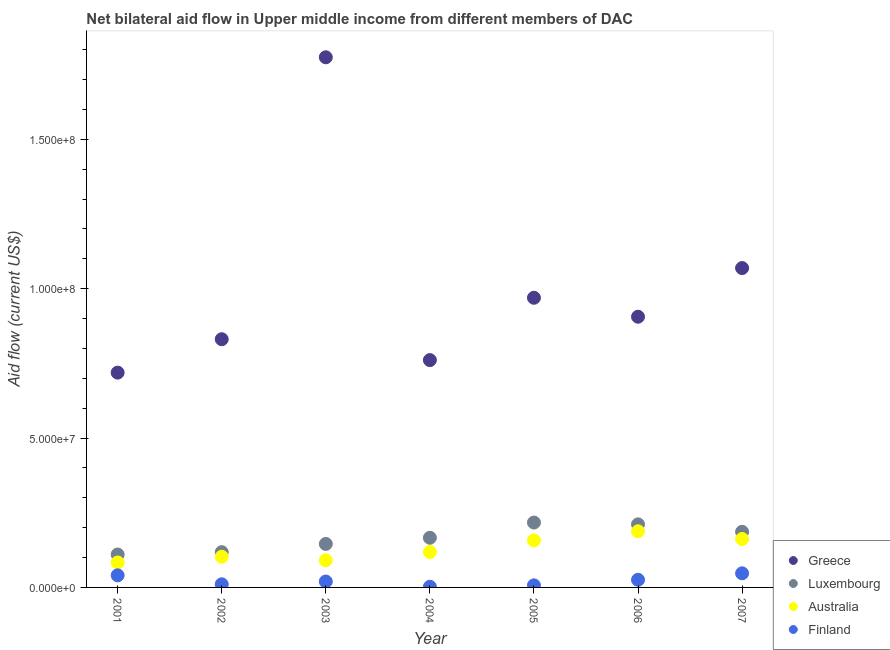How many different coloured dotlines are there?
Provide a short and direct response. 4. Is the number of dotlines equal to the number of legend labels?
Offer a terse response. Yes. What is the amount of aid given by australia in 2006?
Your response must be concise. 1.88e+07. Across all years, what is the maximum amount of aid given by finland?
Your answer should be very brief. 4.72e+06. Across all years, what is the minimum amount of aid given by greece?
Offer a terse response. 7.19e+07. In which year was the amount of aid given by finland maximum?
Provide a succinct answer. 2007. What is the total amount of aid given by greece in the graph?
Offer a very short reply. 7.03e+08. What is the difference between the amount of aid given by finland in 2001 and that in 2007?
Provide a short and direct response. -6.70e+05. What is the difference between the amount of aid given by greece in 2007 and the amount of aid given by finland in 2004?
Ensure brevity in your answer.  1.07e+08. What is the average amount of aid given by luxembourg per year?
Your answer should be compact. 1.65e+07. In the year 2007, what is the difference between the amount of aid given by finland and amount of aid given by greece?
Provide a succinct answer. -1.02e+08. In how many years, is the amount of aid given by finland greater than 120000000 US$?
Give a very brief answer. 0. What is the ratio of the amount of aid given by finland in 2004 to that in 2007?
Provide a succinct answer. 0.05. Is the amount of aid given by luxembourg in 2004 less than that in 2005?
Your response must be concise. Yes. What is the difference between the highest and the second highest amount of aid given by greece?
Your answer should be very brief. 7.06e+07. What is the difference between the highest and the lowest amount of aid given by australia?
Your answer should be compact. 1.04e+07. In how many years, is the amount of aid given by luxembourg greater than the average amount of aid given by luxembourg taken over all years?
Your answer should be very brief. 4. Is it the case that in every year, the sum of the amount of aid given by finland and amount of aid given by australia is greater than the sum of amount of aid given by luxembourg and amount of aid given by greece?
Ensure brevity in your answer.  No. Is the amount of aid given by finland strictly less than the amount of aid given by australia over the years?
Provide a short and direct response. Yes. How many dotlines are there?
Keep it short and to the point. 4. Are the values on the major ticks of Y-axis written in scientific E-notation?
Give a very brief answer. Yes. Does the graph contain grids?
Your answer should be very brief. No. Where does the legend appear in the graph?
Offer a very short reply. Bottom right. How many legend labels are there?
Your answer should be very brief. 4. What is the title of the graph?
Provide a succinct answer. Net bilateral aid flow in Upper middle income from different members of DAC. What is the label or title of the X-axis?
Your response must be concise. Year. What is the Aid flow (current US$) in Greece in 2001?
Your answer should be compact. 7.19e+07. What is the Aid flow (current US$) in Luxembourg in 2001?
Give a very brief answer. 1.10e+07. What is the Aid flow (current US$) in Australia in 2001?
Ensure brevity in your answer.  8.35e+06. What is the Aid flow (current US$) of Finland in 2001?
Your answer should be very brief. 4.05e+06. What is the Aid flow (current US$) of Greece in 2002?
Your answer should be compact. 8.31e+07. What is the Aid flow (current US$) of Luxembourg in 2002?
Your answer should be compact. 1.18e+07. What is the Aid flow (current US$) of Australia in 2002?
Provide a succinct answer. 1.03e+07. What is the Aid flow (current US$) in Finland in 2002?
Your answer should be compact. 1.05e+06. What is the Aid flow (current US$) of Greece in 2003?
Keep it short and to the point. 1.77e+08. What is the Aid flow (current US$) of Luxembourg in 2003?
Your answer should be very brief. 1.46e+07. What is the Aid flow (current US$) of Australia in 2003?
Keep it short and to the point. 9.08e+06. What is the Aid flow (current US$) of Finland in 2003?
Your answer should be very brief. 1.98e+06. What is the Aid flow (current US$) in Greece in 2004?
Keep it short and to the point. 7.61e+07. What is the Aid flow (current US$) of Luxembourg in 2004?
Your answer should be compact. 1.66e+07. What is the Aid flow (current US$) in Australia in 2004?
Give a very brief answer. 1.18e+07. What is the Aid flow (current US$) of Finland in 2004?
Offer a terse response. 2.20e+05. What is the Aid flow (current US$) of Greece in 2005?
Make the answer very short. 9.70e+07. What is the Aid flow (current US$) of Luxembourg in 2005?
Offer a very short reply. 2.17e+07. What is the Aid flow (current US$) in Australia in 2005?
Make the answer very short. 1.58e+07. What is the Aid flow (current US$) of Finland in 2005?
Make the answer very short. 6.90e+05. What is the Aid flow (current US$) of Greece in 2006?
Your answer should be compact. 9.06e+07. What is the Aid flow (current US$) of Luxembourg in 2006?
Keep it short and to the point. 2.11e+07. What is the Aid flow (current US$) in Australia in 2006?
Your answer should be compact. 1.88e+07. What is the Aid flow (current US$) of Finland in 2006?
Offer a very short reply. 2.56e+06. What is the Aid flow (current US$) in Greece in 2007?
Offer a terse response. 1.07e+08. What is the Aid flow (current US$) in Luxembourg in 2007?
Your answer should be compact. 1.86e+07. What is the Aid flow (current US$) in Australia in 2007?
Your answer should be compact. 1.62e+07. What is the Aid flow (current US$) in Finland in 2007?
Your answer should be very brief. 4.72e+06. Across all years, what is the maximum Aid flow (current US$) in Greece?
Your response must be concise. 1.77e+08. Across all years, what is the maximum Aid flow (current US$) in Luxembourg?
Your answer should be compact. 2.17e+07. Across all years, what is the maximum Aid flow (current US$) in Australia?
Give a very brief answer. 1.88e+07. Across all years, what is the maximum Aid flow (current US$) in Finland?
Provide a short and direct response. 4.72e+06. Across all years, what is the minimum Aid flow (current US$) in Greece?
Give a very brief answer. 7.19e+07. Across all years, what is the minimum Aid flow (current US$) of Luxembourg?
Provide a succinct answer. 1.10e+07. Across all years, what is the minimum Aid flow (current US$) of Australia?
Give a very brief answer. 8.35e+06. Across all years, what is the minimum Aid flow (current US$) of Finland?
Ensure brevity in your answer.  2.20e+05. What is the total Aid flow (current US$) of Greece in the graph?
Keep it short and to the point. 7.03e+08. What is the total Aid flow (current US$) in Luxembourg in the graph?
Provide a short and direct response. 1.15e+08. What is the total Aid flow (current US$) of Australia in the graph?
Offer a very short reply. 9.03e+07. What is the total Aid flow (current US$) of Finland in the graph?
Provide a short and direct response. 1.53e+07. What is the difference between the Aid flow (current US$) in Greece in 2001 and that in 2002?
Your answer should be very brief. -1.12e+07. What is the difference between the Aid flow (current US$) in Luxembourg in 2001 and that in 2002?
Provide a short and direct response. -7.80e+05. What is the difference between the Aid flow (current US$) of Australia in 2001 and that in 2002?
Provide a succinct answer. -1.92e+06. What is the difference between the Aid flow (current US$) of Greece in 2001 and that in 2003?
Provide a short and direct response. -1.06e+08. What is the difference between the Aid flow (current US$) in Luxembourg in 2001 and that in 2003?
Offer a very short reply. -3.54e+06. What is the difference between the Aid flow (current US$) of Australia in 2001 and that in 2003?
Give a very brief answer. -7.30e+05. What is the difference between the Aid flow (current US$) in Finland in 2001 and that in 2003?
Ensure brevity in your answer.  2.07e+06. What is the difference between the Aid flow (current US$) of Greece in 2001 and that in 2004?
Your answer should be very brief. -4.19e+06. What is the difference between the Aid flow (current US$) in Luxembourg in 2001 and that in 2004?
Your answer should be very brief. -5.61e+06. What is the difference between the Aid flow (current US$) of Australia in 2001 and that in 2004?
Provide a short and direct response. -3.50e+06. What is the difference between the Aid flow (current US$) of Finland in 2001 and that in 2004?
Provide a short and direct response. 3.83e+06. What is the difference between the Aid flow (current US$) in Greece in 2001 and that in 2005?
Provide a short and direct response. -2.51e+07. What is the difference between the Aid flow (current US$) of Luxembourg in 2001 and that in 2005?
Make the answer very short. -1.07e+07. What is the difference between the Aid flow (current US$) of Australia in 2001 and that in 2005?
Keep it short and to the point. -7.40e+06. What is the difference between the Aid flow (current US$) of Finland in 2001 and that in 2005?
Give a very brief answer. 3.36e+06. What is the difference between the Aid flow (current US$) of Greece in 2001 and that in 2006?
Offer a very short reply. -1.87e+07. What is the difference between the Aid flow (current US$) of Luxembourg in 2001 and that in 2006?
Provide a short and direct response. -1.01e+07. What is the difference between the Aid flow (current US$) of Australia in 2001 and that in 2006?
Offer a terse response. -1.04e+07. What is the difference between the Aid flow (current US$) in Finland in 2001 and that in 2006?
Give a very brief answer. 1.49e+06. What is the difference between the Aid flow (current US$) of Greece in 2001 and that in 2007?
Ensure brevity in your answer.  -3.50e+07. What is the difference between the Aid flow (current US$) of Luxembourg in 2001 and that in 2007?
Offer a terse response. -7.61e+06. What is the difference between the Aid flow (current US$) in Australia in 2001 and that in 2007?
Your response must be concise. -7.87e+06. What is the difference between the Aid flow (current US$) in Finland in 2001 and that in 2007?
Ensure brevity in your answer.  -6.70e+05. What is the difference between the Aid flow (current US$) of Greece in 2002 and that in 2003?
Give a very brief answer. -9.44e+07. What is the difference between the Aid flow (current US$) of Luxembourg in 2002 and that in 2003?
Your answer should be compact. -2.76e+06. What is the difference between the Aid flow (current US$) in Australia in 2002 and that in 2003?
Your answer should be very brief. 1.19e+06. What is the difference between the Aid flow (current US$) in Finland in 2002 and that in 2003?
Your answer should be compact. -9.30e+05. What is the difference between the Aid flow (current US$) of Greece in 2002 and that in 2004?
Ensure brevity in your answer.  6.99e+06. What is the difference between the Aid flow (current US$) of Luxembourg in 2002 and that in 2004?
Give a very brief answer. -4.83e+06. What is the difference between the Aid flow (current US$) in Australia in 2002 and that in 2004?
Ensure brevity in your answer.  -1.58e+06. What is the difference between the Aid flow (current US$) of Finland in 2002 and that in 2004?
Your response must be concise. 8.30e+05. What is the difference between the Aid flow (current US$) in Greece in 2002 and that in 2005?
Your response must be concise. -1.39e+07. What is the difference between the Aid flow (current US$) of Luxembourg in 2002 and that in 2005?
Provide a short and direct response. -9.92e+06. What is the difference between the Aid flow (current US$) in Australia in 2002 and that in 2005?
Make the answer very short. -5.48e+06. What is the difference between the Aid flow (current US$) in Finland in 2002 and that in 2005?
Provide a short and direct response. 3.60e+05. What is the difference between the Aid flow (current US$) of Greece in 2002 and that in 2006?
Provide a succinct answer. -7.53e+06. What is the difference between the Aid flow (current US$) in Luxembourg in 2002 and that in 2006?
Make the answer very short. -9.31e+06. What is the difference between the Aid flow (current US$) of Australia in 2002 and that in 2006?
Offer a very short reply. -8.53e+06. What is the difference between the Aid flow (current US$) in Finland in 2002 and that in 2006?
Offer a terse response. -1.51e+06. What is the difference between the Aid flow (current US$) in Greece in 2002 and that in 2007?
Ensure brevity in your answer.  -2.38e+07. What is the difference between the Aid flow (current US$) of Luxembourg in 2002 and that in 2007?
Offer a very short reply. -6.83e+06. What is the difference between the Aid flow (current US$) of Australia in 2002 and that in 2007?
Provide a short and direct response. -5.95e+06. What is the difference between the Aid flow (current US$) of Finland in 2002 and that in 2007?
Give a very brief answer. -3.67e+06. What is the difference between the Aid flow (current US$) in Greece in 2003 and that in 2004?
Offer a very short reply. 1.01e+08. What is the difference between the Aid flow (current US$) in Luxembourg in 2003 and that in 2004?
Your answer should be very brief. -2.07e+06. What is the difference between the Aid flow (current US$) of Australia in 2003 and that in 2004?
Offer a very short reply. -2.77e+06. What is the difference between the Aid flow (current US$) in Finland in 2003 and that in 2004?
Your response must be concise. 1.76e+06. What is the difference between the Aid flow (current US$) in Greece in 2003 and that in 2005?
Your response must be concise. 8.05e+07. What is the difference between the Aid flow (current US$) in Luxembourg in 2003 and that in 2005?
Offer a terse response. -7.16e+06. What is the difference between the Aid flow (current US$) in Australia in 2003 and that in 2005?
Your answer should be compact. -6.67e+06. What is the difference between the Aid flow (current US$) of Finland in 2003 and that in 2005?
Offer a very short reply. 1.29e+06. What is the difference between the Aid flow (current US$) of Greece in 2003 and that in 2006?
Your answer should be compact. 8.68e+07. What is the difference between the Aid flow (current US$) of Luxembourg in 2003 and that in 2006?
Offer a very short reply. -6.55e+06. What is the difference between the Aid flow (current US$) of Australia in 2003 and that in 2006?
Offer a very short reply. -9.72e+06. What is the difference between the Aid flow (current US$) of Finland in 2003 and that in 2006?
Ensure brevity in your answer.  -5.80e+05. What is the difference between the Aid flow (current US$) in Greece in 2003 and that in 2007?
Offer a very short reply. 7.06e+07. What is the difference between the Aid flow (current US$) of Luxembourg in 2003 and that in 2007?
Your answer should be very brief. -4.07e+06. What is the difference between the Aid flow (current US$) in Australia in 2003 and that in 2007?
Make the answer very short. -7.14e+06. What is the difference between the Aid flow (current US$) in Finland in 2003 and that in 2007?
Make the answer very short. -2.74e+06. What is the difference between the Aid flow (current US$) in Greece in 2004 and that in 2005?
Provide a succinct answer. -2.09e+07. What is the difference between the Aid flow (current US$) of Luxembourg in 2004 and that in 2005?
Ensure brevity in your answer.  -5.09e+06. What is the difference between the Aid flow (current US$) in Australia in 2004 and that in 2005?
Provide a succinct answer. -3.90e+06. What is the difference between the Aid flow (current US$) in Finland in 2004 and that in 2005?
Give a very brief answer. -4.70e+05. What is the difference between the Aid flow (current US$) of Greece in 2004 and that in 2006?
Keep it short and to the point. -1.45e+07. What is the difference between the Aid flow (current US$) in Luxembourg in 2004 and that in 2006?
Offer a very short reply. -4.48e+06. What is the difference between the Aid flow (current US$) in Australia in 2004 and that in 2006?
Provide a succinct answer. -6.95e+06. What is the difference between the Aid flow (current US$) in Finland in 2004 and that in 2006?
Your answer should be very brief. -2.34e+06. What is the difference between the Aid flow (current US$) of Greece in 2004 and that in 2007?
Keep it short and to the point. -3.08e+07. What is the difference between the Aid flow (current US$) in Luxembourg in 2004 and that in 2007?
Give a very brief answer. -2.00e+06. What is the difference between the Aid flow (current US$) of Australia in 2004 and that in 2007?
Make the answer very short. -4.37e+06. What is the difference between the Aid flow (current US$) of Finland in 2004 and that in 2007?
Your answer should be compact. -4.50e+06. What is the difference between the Aid flow (current US$) of Greece in 2005 and that in 2006?
Ensure brevity in your answer.  6.35e+06. What is the difference between the Aid flow (current US$) of Luxembourg in 2005 and that in 2006?
Give a very brief answer. 6.10e+05. What is the difference between the Aid flow (current US$) in Australia in 2005 and that in 2006?
Offer a very short reply. -3.05e+06. What is the difference between the Aid flow (current US$) of Finland in 2005 and that in 2006?
Your response must be concise. -1.87e+06. What is the difference between the Aid flow (current US$) in Greece in 2005 and that in 2007?
Your answer should be very brief. -9.94e+06. What is the difference between the Aid flow (current US$) of Luxembourg in 2005 and that in 2007?
Provide a succinct answer. 3.09e+06. What is the difference between the Aid flow (current US$) in Australia in 2005 and that in 2007?
Provide a succinct answer. -4.70e+05. What is the difference between the Aid flow (current US$) of Finland in 2005 and that in 2007?
Offer a very short reply. -4.03e+06. What is the difference between the Aid flow (current US$) of Greece in 2006 and that in 2007?
Make the answer very short. -1.63e+07. What is the difference between the Aid flow (current US$) of Luxembourg in 2006 and that in 2007?
Make the answer very short. 2.48e+06. What is the difference between the Aid flow (current US$) of Australia in 2006 and that in 2007?
Keep it short and to the point. 2.58e+06. What is the difference between the Aid flow (current US$) in Finland in 2006 and that in 2007?
Keep it short and to the point. -2.16e+06. What is the difference between the Aid flow (current US$) in Greece in 2001 and the Aid flow (current US$) in Luxembourg in 2002?
Offer a terse response. 6.01e+07. What is the difference between the Aid flow (current US$) of Greece in 2001 and the Aid flow (current US$) of Australia in 2002?
Give a very brief answer. 6.16e+07. What is the difference between the Aid flow (current US$) of Greece in 2001 and the Aid flow (current US$) of Finland in 2002?
Make the answer very short. 7.09e+07. What is the difference between the Aid flow (current US$) of Luxembourg in 2001 and the Aid flow (current US$) of Australia in 2002?
Keep it short and to the point. 7.50e+05. What is the difference between the Aid flow (current US$) in Luxembourg in 2001 and the Aid flow (current US$) in Finland in 2002?
Provide a succinct answer. 9.97e+06. What is the difference between the Aid flow (current US$) in Australia in 2001 and the Aid flow (current US$) in Finland in 2002?
Provide a short and direct response. 7.30e+06. What is the difference between the Aid flow (current US$) of Greece in 2001 and the Aid flow (current US$) of Luxembourg in 2003?
Offer a terse response. 5.74e+07. What is the difference between the Aid flow (current US$) in Greece in 2001 and the Aid flow (current US$) in Australia in 2003?
Make the answer very short. 6.28e+07. What is the difference between the Aid flow (current US$) of Greece in 2001 and the Aid flow (current US$) of Finland in 2003?
Make the answer very short. 6.99e+07. What is the difference between the Aid flow (current US$) in Luxembourg in 2001 and the Aid flow (current US$) in Australia in 2003?
Provide a short and direct response. 1.94e+06. What is the difference between the Aid flow (current US$) in Luxembourg in 2001 and the Aid flow (current US$) in Finland in 2003?
Ensure brevity in your answer.  9.04e+06. What is the difference between the Aid flow (current US$) of Australia in 2001 and the Aid flow (current US$) of Finland in 2003?
Your answer should be very brief. 6.37e+06. What is the difference between the Aid flow (current US$) of Greece in 2001 and the Aid flow (current US$) of Luxembourg in 2004?
Keep it short and to the point. 5.53e+07. What is the difference between the Aid flow (current US$) in Greece in 2001 and the Aid flow (current US$) in Australia in 2004?
Your response must be concise. 6.01e+07. What is the difference between the Aid flow (current US$) of Greece in 2001 and the Aid flow (current US$) of Finland in 2004?
Offer a very short reply. 7.17e+07. What is the difference between the Aid flow (current US$) of Luxembourg in 2001 and the Aid flow (current US$) of Australia in 2004?
Offer a terse response. -8.30e+05. What is the difference between the Aid flow (current US$) in Luxembourg in 2001 and the Aid flow (current US$) in Finland in 2004?
Give a very brief answer. 1.08e+07. What is the difference between the Aid flow (current US$) of Australia in 2001 and the Aid flow (current US$) of Finland in 2004?
Offer a terse response. 8.13e+06. What is the difference between the Aid flow (current US$) in Greece in 2001 and the Aid flow (current US$) in Luxembourg in 2005?
Your answer should be very brief. 5.02e+07. What is the difference between the Aid flow (current US$) of Greece in 2001 and the Aid flow (current US$) of Australia in 2005?
Give a very brief answer. 5.62e+07. What is the difference between the Aid flow (current US$) of Greece in 2001 and the Aid flow (current US$) of Finland in 2005?
Offer a very short reply. 7.12e+07. What is the difference between the Aid flow (current US$) in Luxembourg in 2001 and the Aid flow (current US$) in Australia in 2005?
Provide a short and direct response. -4.73e+06. What is the difference between the Aid flow (current US$) in Luxembourg in 2001 and the Aid flow (current US$) in Finland in 2005?
Your response must be concise. 1.03e+07. What is the difference between the Aid flow (current US$) of Australia in 2001 and the Aid flow (current US$) of Finland in 2005?
Ensure brevity in your answer.  7.66e+06. What is the difference between the Aid flow (current US$) of Greece in 2001 and the Aid flow (current US$) of Luxembourg in 2006?
Provide a succinct answer. 5.08e+07. What is the difference between the Aid flow (current US$) of Greece in 2001 and the Aid flow (current US$) of Australia in 2006?
Your response must be concise. 5.31e+07. What is the difference between the Aid flow (current US$) of Greece in 2001 and the Aid flow (current US$) of Finland in 2006?
Offer a terse response. 6.94e+07. What is the difference between the Aid flow (current US$) of Luxembourg in 2001 and the Aid flow (current US$) of Australia in 2006?
Ensure brevity in your answer.  -7.78e+06. What is the difference between the Aid flow (current US$) of Luxembourg in 2001 and the Aid flow (current US$) of Finland in 2006?
Offer a terse response. 8.46e+06. What is the difference between the Aid flow (current US$) in Australia in 2001 and the Aid flow (current US$) in Finland in 2006?
Offer a very short reply. 5.79e+06. What is the difference between the Aid flow (current US$) in Greece in 2001 and the Aid flow (current US$) in Luxembourg in 2007?
Your answer should be very brief. 5.33e+07. What is the difference between the Aid flow (current US$) of Greece in 2001 and the Aid flow (current US$) of Australia in 2007?
Offer a terse response. 5.57e+07. What is the difference between the Aid flow (current US$) in Greece in 2001 and the Aid flow (current US$) in Finland in 2007?
Your answer should be compact. 6.72e+07. What is the difference between the Aid flow (current US$) of Luxembourg in 2001 and the Aid flow (current US$) of Australia in 2007?
Offer a very short reply. -5.20e+06. What is the difference between the Aid flow (current US$) in Luxembourg in 2001 and the Aid flow (current US$) in Finland in 2007?
Provide a short and direct response. 6.30e+06. What is the difference between the Aid flow (current US$) in Australia in 2001 and the Aid flow (current US$) in Finland in 2007?
Keep it short and to the point. 3.63e+06. What is the difference between the Aid flow (current US$) in Greece in 2002 and the Aid flow (current US$) in Luxembourg in 2003?
Provide a short and direct response. 6.85e+07. What is the difference between the Aid flow (current US$) in Greece in 2002 and the Aid flow (current US$) in Australia in 2003?
Give a very brief answer. 7.40e+07. What is the difference between the Aid flow (current US$) of Greece in 2002 and the Aid flow (current US$) of Finland in 2003?
Offer a very short reply. 8.11e+07. What is the difference between the Aid flow (current US$) in Luxembourg in 2002 and the Aid flow (current US$) in Australia in 2003?
Your answer should be compact. 2.72e+06. What is the difference between the Aid flow (current US$) in Luxembourg in 2002 and the Aid flow (current US$) in Finland in 2003?
Keep it short and to the point. 9.82e+06. What is the difference between the Aid flow (current US$) in Australia in 2002 and the Aid flow (current US$) in Finland in 2003?
Provide a succinct answer. 8.29e+06. What is the difference between the Aid flow (current US$) in Greece in 2002 and the Aid flow (current US$) in Luxembourg in 2004?
Your answer should be compact. 6.65e+07. What is the difference between the Aid flow (current US$) of Greece in 2002 and the Aid flow (current US$) of Australia in 2004?
Ensure brevity in your answer.  7.12e+07. What is the difference between the Aid flow (current US$) of Greece in 2002 and the Aid flow (current US$) of Finland in 2004?
Your answer should be compact. 8.29e+07. What is the difference between the Aid flow (current US$) in Luxembourg in 2002 and the Aid flow (current US$) in Finland in 2004?
Your response must be concise. 1.16e+07. What is the difference between the Aid flow (current US$) in Australia in 2002 and the Aid flow (current US$) in Finland in 2004?
Your answer should be compact. 1.00e+07. What is the difference between the Aid flow (current US$) of Greece in 2002 and the Aid flow (current US$) of Luxembourg in 2005?
Provide a short and direct response. 6.14e+07. What is the difference between the Aid flow (current US$) of Greece in 2002 and the Aid flow (current US$) of Australia in 2005?
Make the answer very short. 6.73e+07. What is the difference between the Aid flow (current US$) in Greece in 2002 and the Aid flow (current US$) in Finland in 2005?
Your answer should be very brief. 8.24e+07. What is the difference between the Aid flow (current US$) of Luxembourg in 2002 and the Aid flow (current US$) of Australia in 2005?
Make the answer very short. -3.95e+06. What is the difference between the Aid flow (current US$) in Luxembourg in 2002 and the Aid flow (current US$) in Finland in 2005?
Give a very brief answer. 1.11e+07. What is the difference between the Aid flow (current US$) in Australia in 2002 and the Aid flow (current US$) in Finland in 2005?
Provide a short and direct response. 9.58e+06. What is the difference between the Aid flow (current US$) of Greece in 2002 and the Aid flow (current US$) of Luxembourg in 2006?
Offer a very short reply. 6.20e+07. What is the difference between the Aid flow (current US$) in Greece in 2002 and the Aid flow (current US$) in Australia in 2006?
Offer a terse response. 6.43e+07. What is the difference between the Aid flow (current US$) in Greece in 2002 and the Aid flow (current US$) in Finland in 2006?
Offer a terse response. 8.05e+07. What is the difference between the Aid flow (current US$) of Luxembourg in 2002 and the Aid flow (current US$) of Australia in 2006?
Give a very brief answer. -7.00e+06. What is the difference between the Aid flow (current US$) of Luxembourg in 2002 and the Aid flow (current US$) of Finland in 2006?
Make the answer very short. 9.24e+06. What is the difference between the Aid flow (current US$) in Australia in 2002 and the Aid flow (current US$) in Finland in 2006?
Offer a very short reply. 7.71e+06. What is the difference between the Aid flow (current US$) of Greece in 2002 and the Aid flow (current US$) of Luxembourg in 2007?
Your answer should be compact. 6.45e+07. What is the difference between the Aid flow (current US$) of Greece in 2002 and the Aid flow (current US$) of Australia in 2007?
Ensure brevity in your answer.  6.69e+07. What is the difference between the Aid flow (current US$) of Greece in 2002 and the Aid flow (current US$) of Finland in 2007?
Your answer should be very brief. 7.84e+07. What is the difference between the Aid flow (current US$) in Luxembourg in 2002 and the Aid flow (current US$) in Australia in 2007?
Provide a succinct answer. -4.42e+06. What is the difference between the Aid flow (current US$) in Luxembourg in 2002 and the Aid flow (current US$) in Finland in 2007?
Offer a terse response. 7.08e+06. What is the difference between the Aid flow (current US$) of Australia in 2002 and the Aid flow (current US$) of Finland in 2007?
Provide a succinct answer. 5.55e+06. What is the difference between the Aid flow (current US$) of Greece in 2003 and the Aid flow (current US$) of Luxembourg in 2004?
Your answer should be very brief. 1.61e+08. What is the difference between the Aid flow (current US$) in Greece in 2003 and the Aid flow (current US$) in Australia in 2004?
Offer a very short reply. 1.66e+08. What is the difference between the Aid flow (current US$) of Greece in 2003 and the Aid flow (current US$) of Finland in 2004?
Provide a succinct answer. 1.77e+08. What is the difference between the Aid flow (current US$) of Luxembourg in 2003 and the Aid flow (current US$) of Australia in 2004?
Provide a succinct answer. 2.71e+06. What is the difference between the Aid flow (current US$) of Luxembourg in 2003 and the Aid flow (current US$) of Finland in 2004?
Provide a short and direct response. 1.43e+07. What is the difference between the Aid flow (current US$) of Australia in 2003 and the Aid flow (current US$) of Finland in 2004?
Offer a very short reply. 8.86e+06. What is the difference between the Aid flow (current US$) in Greece in 2003 and the Aid flow (current US$) in Luxembourg in 2005?
Offer a very short reply. 1.56e+08. What is the difference between the Aid flow (current US$) of Greece in 2003 and the Aid flow (current US$) of Australia in 2005?
Your answer should be compact. 1.62e+08. What is the difference between the Aid flow (current US$) in Greece in 2003 and the Aid flow (current US$) in Finland in 2005?
Give a very brief answer. 1.77e+08. What is the difference between the Aid flow (current US$) of Luxembourg in 2003 and the Aid flow (current US$) of Australia in 2005?
Give a very brief answer. -1.19e+06. What is the difference between the Aid flow (current US$) of Luxembourg in 2003 and the Aid flow (current US$) of Finland in 2005?
Provide a succinct answer. 1.39e+07. What is the difference between the Aid flow (current US$) of Australia in 2003 and the Aid flow (current US$) of Finland in 2005?
Ensure brevity in your answer.  8.39e+06. What is the difference between the Aid flow (current US$) of Greece in 2003 and the Aid flow (current US$) of Luxembourg in 2006?
Keep it short and to the point. 1.56e+08. What is the difference between the Aid flow (current US$) in Greece in 2003 and the Aid flow (current US$) in Australia in 2006?
Keep it short and to the point. 1.59e+08. What is the difference between the Aid flow (current US$) in Greece in 2003 and the Aid flow (current US$) in Finland in 2006?
Offer a very short reply. 1.75e+08. What is the difference between the Aid flow (current US$) in Luxembourg in 2003 and the Aid flow (current US$) in Australia in 2006?
Offer a very short reply. -4.24e+06. What is the difference between the Aid flow (current US$) of Luxembourg in 2003 and the Aid flow (current US$) of Finland in 2006?
Ensure brevity in your answer.  1.20e+07. What is the difference between the Aid flow (current US$) of Australia in 2003 and the Aid flow (current US$) of Finland in 2006?
Provide a succinct answer. 6.52e+06. What is the difference between the Aid flow (current US$) in Greece in 2003 and the Aid flow (current US$) in Luxembourg in 2007?
Offer a terse response. 1.59e+08. What is the difference between the Aid flow (current US$) in Greece in 2003 and the Aid flow (current US$) in Australia in 2007?
Offer a terse response. 1.61e+08. What is the difference between the Aid flow (current US$) in Greece in 2003 and the Aid flow (current US$) in Finland in 2007?
Offer a very short reply. 1.73e+08. What is the difference between the Aid flow (current US$) in Luxembourg in 2003 and the Aid flow (current US$) in Australia in 2007?
Ensure brevity in your answer.  -1.66e+06. What is the difference between the Aid flow (current US$) of Luxembourg in 2003 and the Aid flow (current US$) of Finland in 2007?
Give a very brief answer. 9.84e+06. What is the difference between the Aid flow (current US$) of Australia in 2003 and the Aid flow (current US$) of Finland in 2007?
Offer a very short reply. 4.36e+06. What is the difference between the Aid flow (current US$) of Greece in 2004 and the Aid flow (current US$) of Luxembourg in 2005?
Provide a succinct answer. 5.44e+07. What is the difference between the Aid flow (current US$) in Greece in 2004 and the Aid flow (current US$) in Australia in 2005?
Provide a short and direct response. 6.04e+07. What is the difference between the Aid flow (current US$) of Greece in 2004 and the Aid flow (current US$) of Finland in 2005?
Your answer should be very brief. 7.54e+07. What is the difference between the Aid flow (current US$) in Luxembourg in 2004 and the Aid flow (current US$) in Australia in 2005?
Make the answer very short. 8.80e+05. What is the difference between the Aid flow (current US$) of Luxembourg in 2004 and the Aid flow (current US$) of Finland in 2005?
Provide a succinct answer. 1.59e+07. What is the difference between the Aid flow (current US$) of Australia in 2004 and the Aid flow (current US$) of Finland in 2005?
Offer a very short reply. 1.12e+07. What is the difference between the Aid flow (current US$) of Greece in 2004 and the Aid flow (current US$) of Luxembourg in 2006?
Your answer should be very brief. 5.50e+07. What is the difference between the Aid flow (current US$) of Greece in 2004 and the Aid flow (current US$) of Australia in 2006?
Your response must be concise. 5.73e+07. What is the difference between the Aid flow (current US$) in Greece in 2004 and the Aid flow (current US$) in Finland in 2006?
Keep it short and to the point. 7.35e+07. What is the difference between the Aid flow (current US$) of Luxembourg in 2004 and the Aid flow (current US$) of Australia in 2006?
Offer a terse response. -2.17e+06. What is the difference between the Aid flow (current US$) of Luxembourg in 2004 and the Aid flow (current US$) of Finland in 2006?
Provide a short and direct response. 1.41e+07. What is the difference between the Aid flow (current US$) of Australia in 2004 and the Aid flow (current US$) of Finland in 2006?
Provide a short and direct response. 9.29e+06. What is the difference between the Aid flow (current US$) of Greece in 2004 and the Aid flow (current US$) of Luxembourg in 2007?
Keep it short and to the point. 5.75e+07. What is the difference between the Aid flow (current US$) in Greece in 2004 and the Aid flow (current US$) in Australia in 2007?
Your answer should be very brief. 5.99e+07. What is the difference between the Aid flow (current US$) of Greece in 2004 and the Aid flow (current US$) of Finland in 2007?
Keep it short and to the point. 7.14e+07. What is the difference between the Aid flow (current US$) of Luxembourg in 2004 and the Aid flow (current US$) of Australia in 2007?
Your response must be concise. 4.10e+05. What is the difference between the Aid flow (current US$) of Luxembourg in 2004 and the Aid flow (current US$) of Finland in 2007?
Provide a short and direct response. 1.19e+07. What is the difference between the Aid flow (current US$) in Australia in 2004 and the Aid flow (current US$) in Finland in 2007?
Ensure brevity in your answer.  7.13e+06. What is the difference between the Aid flow (current US$) in Greece in 2005 and the Aid flow (current US$) in Luxembourg in 2006?
Give a very brief answer. 7.59e+07. What is the difference between the Aid flow (current US$) in Greece in 2005 and the Aid flow (current US$) in Australia in 2006?
Keep it short and to the point. 7.82e+07. What is the difference between the Aid flow (current US$) in Greece in 2005 and the Aid flow (current US$) in Finland in 2006?
Ensure brevity in your answer.  9.44e+07. What is the difference between the Aid flow (current US$) of Luxembourg in 2005 and the Aid flow (current US$) of Australia in 2006?
Make the answer very short. 2.92e+06. What is the difference between the Aid flow (current US$) of Luxembourg in 2005 and the Aid flow (current US$) of Finland in 2006?
Keep it short and to the point. 1.92e+07. What is the difference between the Aid flow (current US$) of Australia in 2005 and the Aid flow (current US$) of Finland in 2006?
Offer a very short reply. 1.32e+07. What is the difference between the Aid flow (current US$) of Greece in 2005 and the Aid flow (current US$) of Luxembourg in 2007?
Give a very brief answer. 7.83e+07. What is the difference between the Aid flow (current US$) in Greece in 2005 and the Aid flow (current US$) in Australia in 2007?
Provide a short and direct response. 8.08e+07. What is the difference between the Aid flow (current US$) in Greece in 2005 and the Aid flow (current US$) in Finland in 2007?
Provide a short and direct response. 9.22e+07. What is the difference between the Aid flow (current US$) in Luxembourg in 2005 and the Aid flow (current US$) in Australia in 2007?
Your response must be concise. 5.50e+06. What is the difference between the Aid flow (current US$) in Luxembourg in 2005 and the Aid flow (current US$) in Finland in 2007?
Make the answer very short. 1.70e+07. What is the difference between the Aid flow (current US$) in Australia in 2005 and the Aid flow (current US$) in Finland in 2007?
Ensure brevity in your answer.  1.10e+07. What is the difference between the Aid flow (current US$) of Greece in 2006 and the Aid flow (current US$) of Luxembourg in 2007?
Offer a very short reply. 7.20e+07. What is the difference between the Aid flow (current US$) in Greece in 2006 and the Aid flow (current US$) in Australia in 2007?
Provide a short and direct response. 7.44e+07. What is the difference between the Aid flow (current US$) of Greece in 2006 and the Aid flow (current US$) of Finland in 2007?
Offer a terse response. 8.59e+07. What is the difference between the Aid flow (current US$) in Luxembourg in 2006 and the Aid flow (current US$) in Australia in 2007?
Provide a succinct answer. 4.89e+06. What is the difference between the Aid flow (current US$) in Luxembourg in 2006 and the Aid flow (current US$) in Finland in 2007?
Keep it short and to the point. 1.64e+07. What is the difference between the Aid flow (current US$) of Australia in 2006 and the Aid flow (current US$) of Finland in 2007?
Your response must be concise. 1.41e+07. What is the average Aid flow (current US$) of Greece per year?
Offer a very short reply. 1.00e+08. What is the average Aid flow (current US$) in Luxembourg per year?
Provide a succinct answer. 1.65e+07. What is the average Aid flow (current US$) in Australia per year?
Offer a terse response. 1.29e+07. What is the average Aid flow (current US$) of Finland per year?
Offer a terse response. 2.18e+06. In the year 2001, what is the difference between the Aid flow (current US$) of Greece and Aid flow (current US$) of Luxembourg?
Provide a succinct answer. 6.09e+07. In the year 2001, what is the difference between the Aid flow (current US$) of Greece and Aid flow (current US$) of Australia?
Give a very brief answer. 6.36e+07. In the year 2001, what is the difference between the Aid flow (current US$) of Greece and Aid flow (current US$) of Finland?
Offer a terse response. 6.79e+07. In the year 2001, what is the difference between the Aid flow (current US$) in Luxembourg and Aid flow (current US$) in Australia?
Offer a terse response. 2.67e+06. In the year 2001, what is the difference between the Aid flow (current US$) in Luxembourg and Aid flow (current US$) in Finland?
Your response must be concise. 6.97e+06. In the year 2001, what is the difference between the Aid flow (current US$) of Australia and Aid flow (current US$) of Finland?
Provide a short and direct response. 4.30e+06. In the year 2002, what is the difference between the Aid flow (current US$) of Greece and Aid flow (current US$) of Luxembourg?
Provide a succinct answer. 7.13e+07. In the year 2002, what is the difference between the Aid flow (current US$) in Greece and Aid flow (current US$) in Australia?
Ensure brevity in your answer.  7.28e+07. In the year 2002, what is the difference between the Aid flow (current US$) in Greece and Aid flow (current US$) in Finland?
Provide a succinct answer. 8.20e+07. In the year 2002, what is the difference between the Aid flow (current US$) of Luxembourg and Aid flow (current US$) of Australia?
Ensure brevity in your answer.  1.53e+06. In the year 2002, what is the difference between the Aid flow (current US$) of Luxembourg and Aid flow (current US$) of Finland?
Your answer should be very brief. 1.08e+07. In the year 2002, what is the difference between the Aid flow (current US$) of Australia and Aid flow (current US$) of Finland?
Offer a terse response. 9.22e+06. In the year 2003, what is the difference between the Aid flow (current US$) in Greece and Aid flow (current US$) in Luxembourg?
Your response must be concise. 1.63e+08. In the year 2003, what is the difference between the Aid flow (current US$) in Greece and Aid flow (current US$) in Australia?
Your answer should be compact. 1.68e+08. In the year 2003, what is the difference between the Aid flow (current US$) of Greece and Aid flow (current US$) of Finland?
Your answer should be very brief. 1.75e+08. In the year 2003, what is the difference between the Aid flow (current US$) of Luxembourg and Aid flow (current US$) of Australia?
Offer a terse response. 5.48e+06. In the year 2003, what is the difference between the Aid flow (current US$) of Luxembourg and Aid flow (current US$) of Finland?
Offer a very short reply. 1.26e+07. In the year 2003, what is the difference between the Aid flow (current US$) in Australia and Aid flow (current US$) in Finland?
Your response must be concise. 7.10e+06. In the year 2004, what is the difference between the Aid flow (current US$) in Greece and Aid flow (current US$) in Luxembourg?
Offer a terse response. 5.95e+07. In the year 2004, what is the difference between the Aid flow (current US$) of Greece and Aid flow (current US$) of Australia?
Provide a succinct answer. 6.42e+07. In the year 2004, what is the difference between the Aid flow (current US$) of Greece and Aid flow (current US$) of Finland?
Offer a terse response. 7.59e+07. In the year 2004, what is the difference between the Aid flow (current US$) of Luxembourg and Aid flow (current US$) of Australia?
Ensure brevity in your answer.  4.78e+06. In the year 2004, what is the difference between the Aid flow (current US$) in Luxembourg and Aid flow (current US$) in Finland?
Provide a short and direct response. 1.64e+07. In the year 2004, what is the difference between the Aid flow (current US$) in Australia and Aid flow (current US$) in Finland?
Your answer should be compact. 1.16e+07. In the year 2005, what is the difference between the Aid flow (current US$) of Greece and Aid flow (current US$) of Luxembourg?
Provide a short and direct response. 7.52e+07. In the year 2005, what is the difference between the Aid flow (current US$) of Greece and Aid flow (current US$) of Australia?
Make the answer very short. 8.12e+07. In the year 2005, what is the difference between the Aid flow (current US$) in Greece and Aid flow (current US$) in Finland?
Your answer should be compact. 9.63e+07. In the year 2005, what is the difference between the Aid flow (current US$) in Luxembourg and Aid flow (current US$) in Australia?
Keep it short and to the point. 5.97e+06. In the year 2005, what is the difference between the Aid flow (current US$) of Luxembourg and Aid flow (current US$) of Finland?
Provide a succinct answer. 2.10e+07. In the year 2005, what is the difference between the Aid flow (current US$) in Australia and Aid flow (current US$) in Finland?
Your answer should be compact. 1.51e+07. In the year 2006, what is the difference between the Aid flow (current US$) in Greece and Aid flow (current US$) in Luxembourg?
Your response must be concise. 6.95e+07. In the year 2006, what is the difference between the Aid flow (current US$) in Greece and Aid flow (current US$) in Australia?
Your response must be concise. 7.18e+07. In the year 2006, what is the difference between the Aid flow (current US$) of Greece and Aid flow (current US$) of Finland?
Keep it short and to the point. 8.81e+07. In the year 2006, what is the difference between the Aid flow (current US$) in Luxembourg and Aid flow (current US$) in Australia?
Make the answer very short. 2.31e+06. In the year 2006, what is the difference between the Aid flow (current US$) of Luxembourg and Aid flow (current US$) of Finland?
Your response must be concise. 1.86e+07. In the year 2006, what is the difference between the Aid flow (current US$) of Australia and Aid flow (current US$) of Finland?
Your answer should be compact. 1.62e+07. In the year 2007, what is the difference between the Aid flow (current US$) in Greece and Aid flow (current US$) in Luxembourg?
Provide a short and direct response. 8.83e+07. In the year 2007, what is the difference between the Aid flow (current US$) of Greece and Aid flow (current US$) of Australia?
Your answer should be very brief. 9.07e+07. In the year 2007, what is the difference between the Aid flow (current US$) in Greece and Aid flow (current US$) in Finland?
Offer a very short reply. 1.02e+08. In the year 2007, what is the difference between the Aid flow (current US$) in Luxembourg and Aid flow (current US$) in Australia?
Offer a terse response. 2.41e+06. In the year 2007, what is the difference between the Aid flow (current US$) in Luxembourg and Aid flow (current US$) in Finland?
Offer a terse response. 1.39e+07. In the year 2007, what is the difference between the Aid flow (current US$) of Australia and Aid flow (current US$) of Finland?
Keep it short and to the point. 1.15e+07. What is the ratio of the Aid flow (current US$) of Greece in 2001 to that in 2002?
Offer a very short reply. 0.87. What is the ratio of the Aid flow (current US$) in Luxembourg in 2001 to that in 2002?
Keep it short and to the point. 0.93. What is the ratio of the Aid flow (current US$) in Australia in 2001 to that in 2002?
Your answer should be compact. 0.81. What is the ratio of the Aid flow (current US$) of Finland in 2001 to that in 2002?
Ensure brevity in your answer.  3.86. What is the ratio of the Aid flow (current US$) of Greece in 2001 to that in 2003?
Give a very brief answer. 0.41. What is the ratio of the Aid flow (current US$) in Luxembourg in 2001 to that in 2003?
Your answer should be very brief. 0.76. What is the ratio of the Aid flow (current US$) in Australia in 2001 to that in 2003?
Offer a terse response. 0.92. What is the ratio of the Aid flow (current US$) in Finland in 2001 to that in 2003?
Give a very brief answer. 2.05. What is the ratio of the Aid flow (current US$) in Greece in 2001 to that in 2004?
Provide a succinct answer. 0.94. What is the ratio of the Aid flow (current US$) in Luxembourg in 2001 to that in 2004?
Your answer should be very brief. 0.66. What is the ratio of the Aid flow (current US$) in Australia in 2001 to that in 2004?
Give a very brief answer. 0.7. What is the ratio of the Aid flow (current US$) in Finland in 2001 to that in 2004?
Your response must be concise. 18.41. What is the ratio of the Aid flow (current US$) of Greece in 2001 to that in 2005?
Give a very brief answer. 0.74. What is the ratio of the Aid flow (current US$) in Luxembourg in 2001 to that in 2005?
Your response must be concise. 0.51. What is the ratio of the Aid flow (current US$) in Australia in 2001 to that in 2005?
Offer a very short reply. 0.53. What is the ratio of the Aid flow (current US$) in Finland in 2001 to that in 2005?
Provide a short and direct response. 5.87. What is the ratio of the Aid flow (current US$) in Greece in 2001 to that in 2006?
Offer a terse response. 0.79. What is the ratio of the Aid flow (current US$) in Luxembourg in 2001 to that in 2006?
Keep it short and to the point. 0.52. What is the ratio of the Aid flow (current US$) of Australia in 2001 to that in 2006?
Provide a succinct answer. 0.44. What is the ratio of the Aid flow (current US$) in Finland in 2001 to that in 2006?
Your response must be concise. 1.58. What is the ratio of the Aid flow (current US$) of Greece in 2001 to that in 2007?
Your response must be concise. 0.67. What is the ratio of the Aid flow (current US$) in Luxembourg in 2001 to that in 2007?
Make the answer very short. 0.59. What is the ratio of the Aid flow (current US$) of Australia in 2001 to that in 2007?
Provide a short and direct response. 0.51. What is the ratio of the Aid flow (current US$) of Finland in 2001 to that in 2007?
Offer a very short reply. 0.86. What is the ratio of the Aid flow (current US$) of Greece in 2002 to that in 2003?
Your answer should be compact. 0.47. What is the ratio of the Aid flow (current US$) of Luxembourg in 2002 to that in 2003?
Keep it short and to the point. 0.81. What is the ratio of the Aid flow (current US$) of Australia in 2002 to that in 2003?
Offer a terse response. 1.13. What is the ratio of the Aid flow (current US$) in Finland in 2002 to that in 2003?
Provide a succinct answer. 0.53. What is the ratio of the Aid flow (current US$) in Greece in 2002 to that in 2004?
Make the answer very short. 1.09. What is the ratio of the Aid flow (current US$) in Luxembourg in 2002 to that in 2004?
Offer a very short reply. 0.71. What is the ratio of the Aid flow (current US$) of Australia in 2002 to that in 2004?
Ensure brevity in your answer.  0.87. What is the ratio of the Aid flow (current US$) of Finland in 2002 to that in 2004?
Keep it short and to the point. 4.77. What is the ratio of the Aid flow (current US$) of Greece in 2002 to that in 2005?
Your response must be concise. 0.86. What is the ratio of the Aid flow (current US$) in Luxembourg in 2002 to that in 2005?
Offer a terse response. 0.54. What is the ratio of the Aid flow (current US$) in Australia in 2002 to that in 2005?
Your response must be concise. 0.65. What is the ratio of the Aid flow (current US$) of Finland in 2002 to that in 2005?
Your answer should be very brief. 1.52. What is the ratio of the Aid flow (current US$) in Greece in 2002 to that in 2006?
Keep it short and to the point. 0.92. What is the ratio of the Aid flow (current US$) of Luxembourg in 2002 to that in 2006?
Provide a succinct answer. 0.56. What is the ratio of the Aid flow (current US$) in Australia in 2002 to that in 2006?
Provide a short and direct response. 0.55. What is the ratio of the Aid flow (current US$) in Finland in 2002 to that in 2006?
Make the answer very short. 0.41. What is the ratio of the Aid flow (current US$) in Greece in 2002 to that in 2007?
Your response must be concise. 0.78. What is the ratio of the Aid flow (current US$) in Luxembourg in 2002 to that in 2007?
Make the answer very short. 0.63. What is the ratio of the Aid flow (current US$) of Australia in 2002 to that in 2007?
Offer a terse response. 0.63. What is the ratio of the Aid flow (current US$) of Finland in 2002 to that in 2007?
Make the answer very short. 0.22. What is the ratio of the Aid flow (current US$) in Greece in 2003 to that in 2004?
Offer a terse response. 2.33. What is the ratio of the Aid flow (current US$) in Luxembourg in 2003 to that in 2004?
Your answer should be compact. 0.88. What is the ratio of the Aid flow (current US$) of Australia in 2003 to that in 2004?
Provide a short and direct response. 0.77. What is the ratio of the Aid flow (current US$) of Finland in 2003 to that in 2004?
Give a very brief answer. 9. What is the ratio of the Aid flow (current US$) in Greece in 2003 to that in 2005?
Make the answer very short. 1.83. What is the ratio of the Aid flow (current US$) of Luxembourg in 2003 to that in 2005?
Make the answer very short. 0.67. What is the ratio of the Aid flow (current US$) in Australia in 2003 to that in 2005?
Make the answer very short. 0.58. What is the ratio of the Aid flow (current US$) of Finland in 2003 to that in 2005?
Make the answer very short. 2.87. What is the ratio of the Aid flow (current US$) of Greece in 2003 to that in 2006?
Offer a terse response. 1.96. What is the ratio of the Aid flow (current US$) of Luxembourg in 2003 to that in 2006?
Your answer should be very brief. 0.69. What is the ratio of the Aid flow (current US$) of Australia in 2003 to that in 2006?
Keep it short and to the point. 0.48. What is the ratio of the Aid flow (current US$) of Finland in 2003 to that in 2006?
Offer a very short reply. 0.77. What is the ratio of the Aid flow (current US$) in Greece in 2003 to that in 2007?
Give a very brief answer. 1.66. What is the ratio of the Aid flow (current US$) in Luxembourg in 2003 to that in 2007?
Offer a terse response. 0.78. What is the ratio of the Aid flow (current US$) in Australia in 2003 to that in 2007?
Provide a short and direct response. 0.56. What is the ratio of the Aid flow (current US$) of Finland in 2003 to that in 2007?
Provide a succinct answer. 0.42. What is the ratio of the Aid flow (current US$) in Greece in 2004 to that in 2005?
Your answer should be compact. 0.78. What is the ratio of the Aid flow (current US$) in Luxembourg in 2004 to that in 2005?
Provide a succinct answer. 0.77. What is the ratio of the Aid flow (current US$) in Australia in 2004 to that in 2005?
Make the answer very short. 0.75. What is the ratio of the Aid flow (current US$) in Finland in 2004 to that in 2005?
Your answer should be compact. 0.32. What is the ratio of the Aid flow (current US$) of Greece in 2004 to that in 2006?
Provide a short and direct response. 0.84. What is the ratio of the Aid flow (current US$) in Luxembourg in 2004 to that in 2006?
Offer a very short reply. 0.79. What is the ratio of the Aid flow (current US$) in Australia in 2004 to that in 2006?
Provide a succinct answer. 0.63. What is the ratio of the Aid flow (current US$) of Finland in 2004 to that in 2006?
Offer a very short reply. 0.09. What is the ratio of the Aid flow (current US$) in Greece in 2004 to that in 2007?
Offer a very short reply. 0.71. What is the ratio of the Aid flow (current US$) in Luxembourg in 2004 to that in 2007?
Keep it short and to the point. 0.89. What is the ratio of the Aid flow (current US$) of Australia in 2004 to that in 2007?
Ensure brevity in your answer.  0.73. What is the ratio of the Aid flow (current US$) of Finland in 2004 to that in 2007?
Provide a short and direct response. 0.05. What is the ratio of the Aid flow (current US$) of Greece in 2005 to that in 2006?
Keep it short and to the point. 1.07. What is the ratio of the Aid flow (current US$) in Luxembourg in 2005 to that in 2006?
Provide a short and direct response. 1.03. What is the ratio of the Aid flow (current US$) in Australia in 2005 to that in 2006?
Provide a short and direct response. 0.84. What is the ratio of the Aid flow (current US$) in Finland in 2005 to that in 2006?
Your answer should be compact. 0.27. What is the ratio of the Aid flow (current US$) in Greece in 2005 to that in 2007?
Offer a terse response. 0.91. What is the ratio of the Aid flow (current US$) in Luxembourg in 2005 to that in 2007?
Offer a very short reply. 1.17. What is the ratio of the Aid flow (current US$) in Australia in 2005 to that in 2007?
Offer a very short reply. 0.97. What is the ratio of the Aid flow (current US$) of Finland in 2005 to that in 2007?
Offer a very short reply. 0.15. What is the ratio of the Aid flow (current US$) in Greece in 2006 to that in 2007?
Offer a terse response. 0.85. What is the ratio of the Aid flow (current US$) of Luxembourg in 2006 to that in 2007?
Your response must be concise. 1.13. What is the ratio of the Aid flow (current US$) in Australia in 2006 to that in 2007?
Provide a short and direct response. 1.16. What is the ratio of the Aid flow (current US$) in Finland in 2006 to that in 2007?
Make the answer very short. 0.54. What is the difference between the highest and the second highest Aid flow (current US$) in Greece?
Offer a terse response. 7.06e+07. What is the difference between the highest and the second highest Aid flow (current US$) of Australia?
Offer a very short reply. 2.58e+06. What is the difference between the highest and the second highest Aid flow (current US$) of Finland?
Your answer should be very brief. 6.70e+05. What is the difference between the highest and the lowest Aid flow (current US$) of Greece?
Provide a succinct answer. 1.06e+08. What is the difference between the highest and the lowest Aid flow (current US$) in Luxembourg?
Offer a very short reply. 1.07e+07. What is the difference between the highest and the lowest Aid flow (current US$) in Australia?
Offer a very short reply. 1.04e+07. What is the difference between the highest and the lowest Aid flow (current US$) in Finland?
Ensure brevity in your answer.  4.50e+06. 